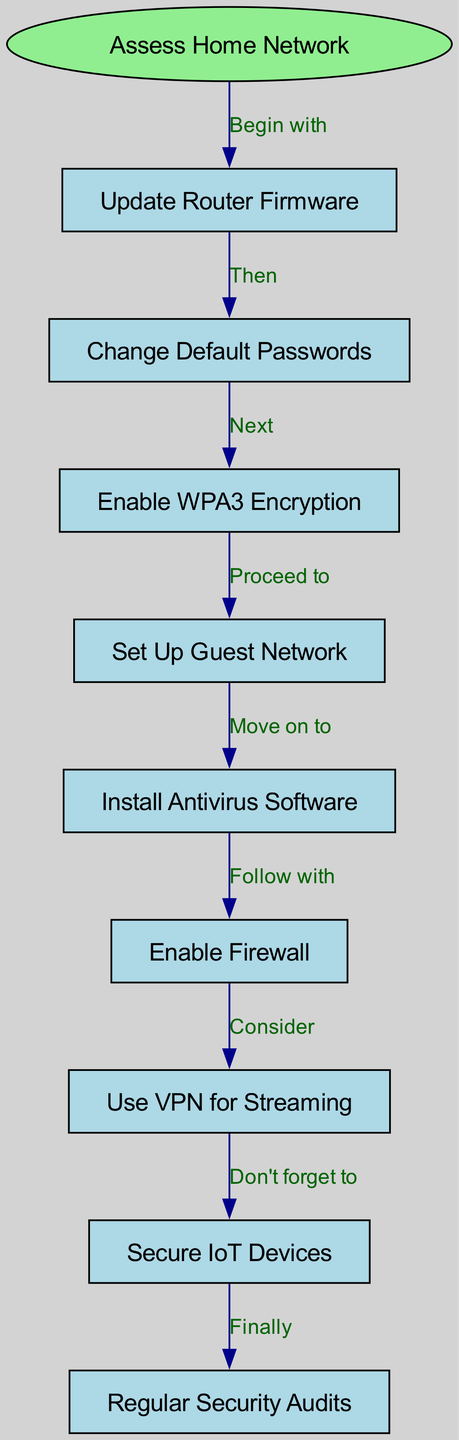What is the starting point of the flow chart? The starting point of the flow chart is labeled "Assess Home Network". This is the first node indicated at the top of the diagram, which serves as the entry point for the process.
Answer: Assess Home Network How many nodes are present in the diagram? The diagram contains a total of 10 nodes. This includes the start node "Assess Home Network" and the subsequent nodes, which are listed in the data provided.
Answer: 10 What comes after "Update Router Firmware"? Following "Update Router Firmware", the next step is "Change Default Passwords". This is indicated by the directed edge connecting these two nodes in the flow.
Answer: Change Default Passwords What is the last step in the flow chart? The last step in the flow chart is "Regular Security Audits". This is the final node reached in the sequence after all previous actions have been taken.
Answer: Regular Security Audits How does "Enable Firewall" connect to the next step? "Enable Firewall" connects to "Use VPN for Streaming". The edge labeled "Consider" shows the direction and suggests that using a VPN is a consideration following firewall activation.
Answer: Use VPN for Streaming What is required before setting up a guest network? Before setting up a guest network, one must enable WPA3 Encryption. The flow indicates that this is the necessary step that must be completed first.
Answer: Enable WPA3 Encryption Which action should be taken directly after installing antivirus software? Directly following the installation of antivirus software, the next action is to "Enable Firewall". This sequence is directed and shows the logical progression of securing the network.
Answer: Enable Firewall How many edges connect the nodes in the flow chart? There are 9 edges connecting the nodes in the flow chart. Each edge represents a directional step from one action to the next throughout the process.
Answer: 9 What should be done after securing IoT devices? After securing IoT devices, the final step indicated is "Regular Security Audits". This shows that ongoing assessments are necessary after securing devices.
Answer: Regular Security Audits 